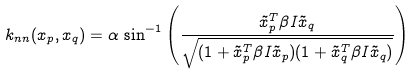Convert formula to latex. <formula><loc_0><loc_0><loc_500><loc_500>k _ { n n } ( { x } _ { p } , { x } _ { q } ) = \alpha \, \sin ^ { - 1 } \left ( \frac { \tilde { x } _ { p } ^ { T } \beta I \tilde { x } _ { q } } { \sqrt { ( 1 + \tilde { x } _ { p } ^ { T } \beta I \tilde { x } _ { p } ) ( 1 + \tilde { x } _ { q } ^ { T } \beta I \tilde { x } _ { q } ) } } \right )</formula> 